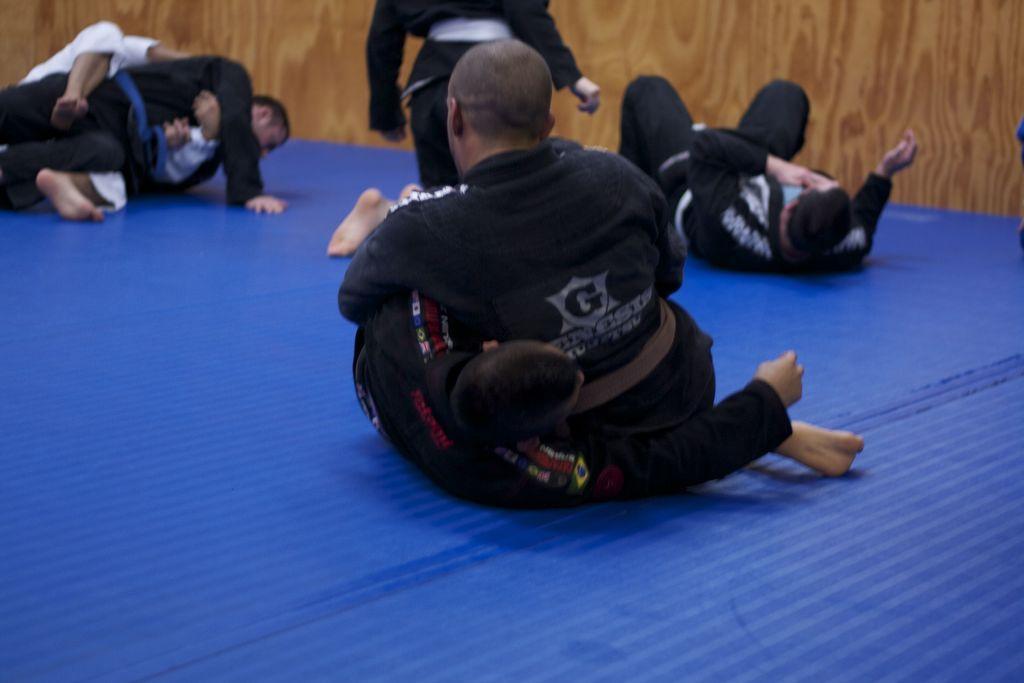Please provide a concise description of this image. In this image there is a person lying on the floor is having a person beside to him. He is leaning into him. Beside there is a person lying on the floor. A person is standing. There are two persons at the left side of image. Behind them there is a wooden wall. 